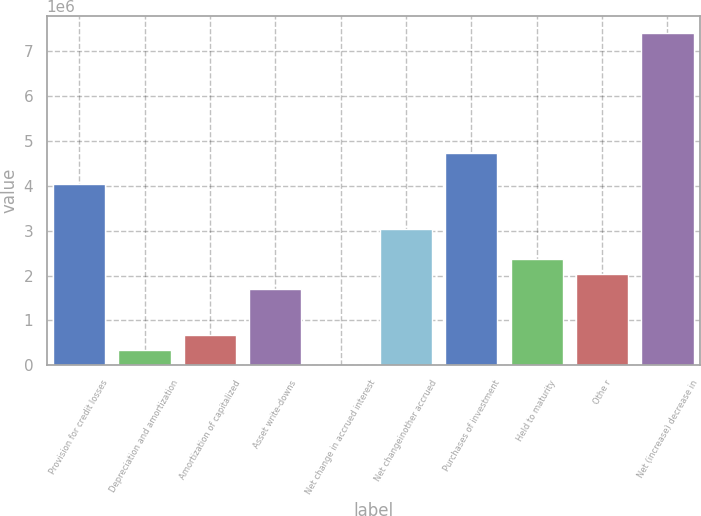<chart> <loc_0><loc_0><loc_500><loc_500><bar_chart><fcel>Provision for credit losses<fcel>Depreciation and amortization<fcel>Amortization of capitalized<fcel>Asset write-downs<fcel>Net change in accrued interest<fcel>Net changeinother accrued<fcel>Purchases of investment<fcel>Held to maturity<fcel>Othe r<fcel>Net (increase) decrease in<nl><fcel>4.04606e+06<fcel>350943<fcel>686862<fcel>1.69462e+06<fcel>15023<fcel>3.0383e+06<fcel>4.7179e+06<fcel>2.36646e+06<fcel>2.03054e+06<fcel>7.40525e+06<nl></chart> 